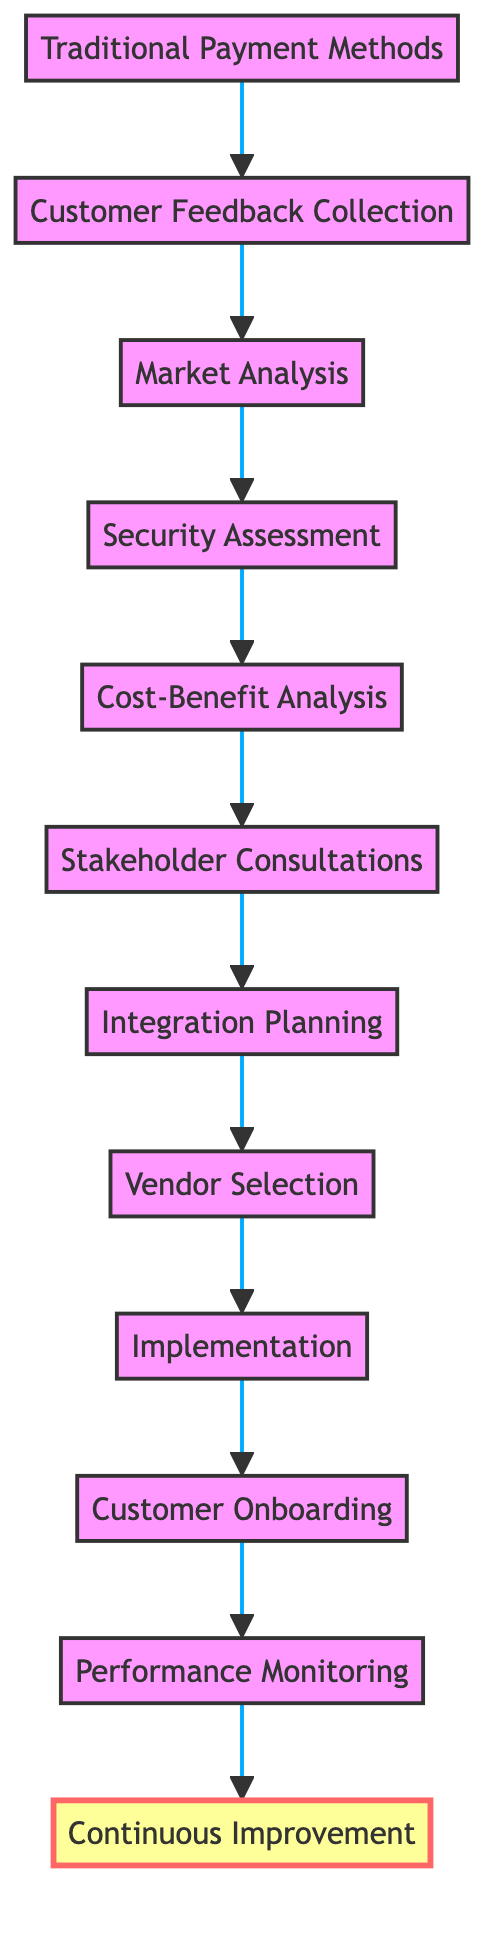What is the first step in the transition process? The flow chart indicates that "Traditional Payment Methods" is the first step in the process, setting the stage for subsequent evaluations and analyses.
Answer: Traditional Payment Methods How many elements are involved in the transition process? The diagram lists a total of 12 elements or steps in transitioning to digital payment gateways, each representing a crucial phase in the overall process.
Answer: 12 What follows after "Security Assessment"? According to the diagram, after "Security Assessment," the next step is "Cost-Benefit Analysis," where the costs and benefits associated with different payment methods are evaluated.
Answer: Cost-Benefit Analysis Which step involves engaging with stakeholders? The diagram shows "Stakeholder Consultations" as the step where engagement with both internal and external stakeholders takes place to discuss transition plans.
Answer: Stakeholder Consultations What does the final step focus on? The last step in the flow chart is "Continuous Improvement," focusing on the ongoing process of enhancing the digital payment methods based on feedback and market trends.
Answer: Continuous Improvement What is the purpose of "Customer Feedback Collection"? The purpose of "Customer Feedback Collection" is to gather insights about customers' pain points and their preferences with regard to traditional payment methods, which informs better decision-making.
Answer: Gather feedback At what stage does "Implementation" occur in the process? "Implementation" occurs after "Vendor Selection," where the organization carries out the chosen payment solutions based on previously established plans and analyses.
Answer: After Vendor Selection What key aspect is assessed during "Security Assessment"? During "Security Assessment," the key aspect evaluated is the compliance of digital payment gateways with industry standards and the security features they offer to prevent fraud and protect user data.
Answer: Security features How does "Market Analysis" contribute to the process? "Market Analysis" contributes by providing insights into current trends in digital payments and identifying popular digital payment gateways, which shapes the choice of solutions for the transition.
Answer: Identify popular gateways What is the action involved in "Customer Onboarding"? "Customer Onboarding" involves launching a campaign aimed at educating users on the benefits of new digital payment options and training them on their effective use.
Answer: Educate users 